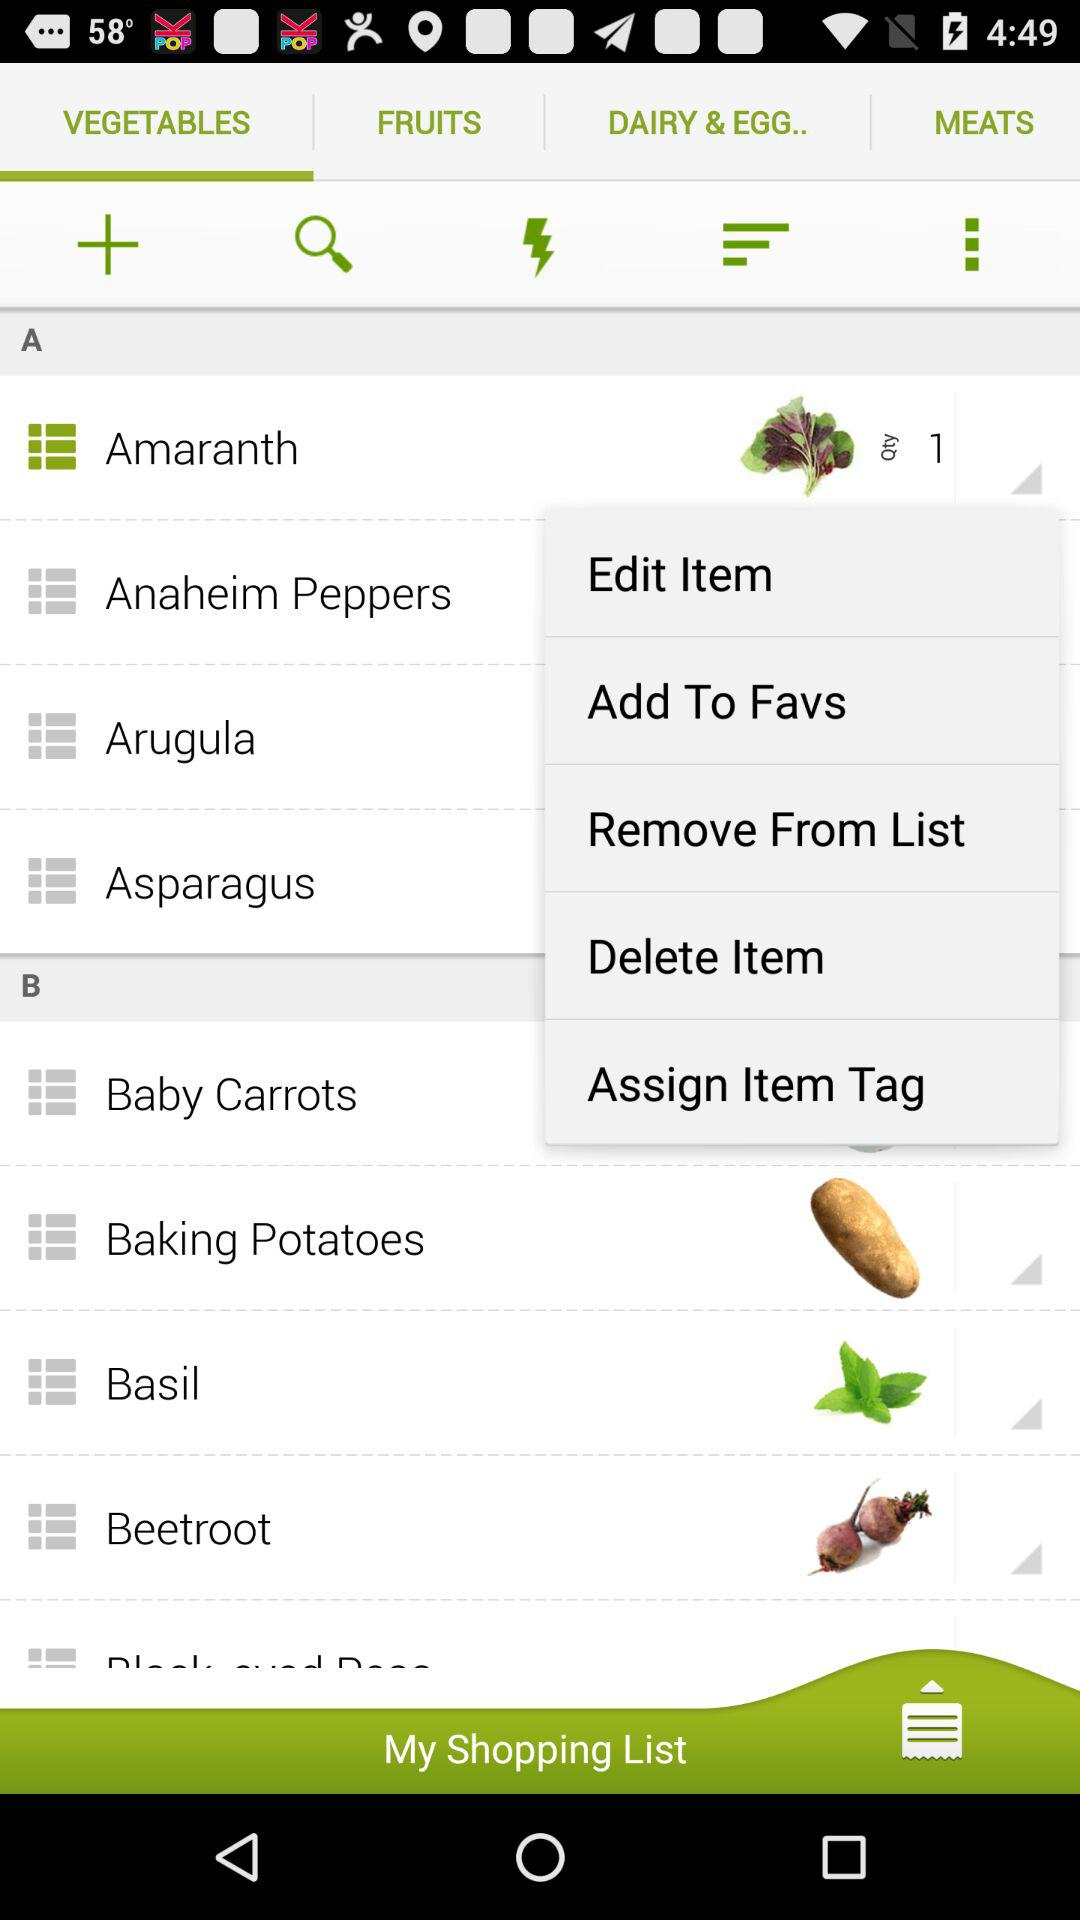What is the quantity? The quantity is 1. 